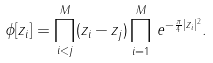Convert formula to latex. <formula><loc_0><loc_0><loc_500><loc_500>\phi [ z _ { i } ] = \prod _ { i < j } ^ { M } ( z _ { i } - z _ { j } ) \prod _ { i = 1 } ^ { M } \, e ^ { - \frac { \pi } { 4 } | z _ { i } | ^ { 2 } } .</formula> 